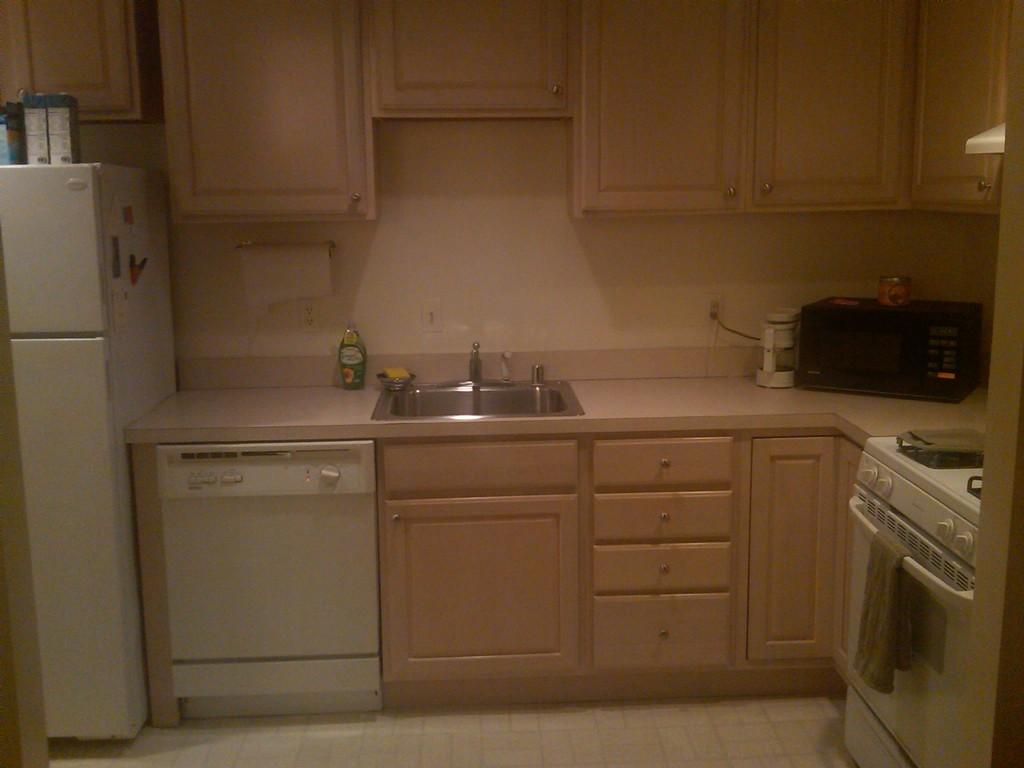What type of appliance is present in the image? There is a fridge in the image. What can be found on the shelves in the image? There are bottles in the image. What type of furniture is present in the image? There is a kitchen cabinet in the image. What is used for washing in the image? There is a sink in the image. What type of appliance is used for grinding in the image? There is a grinder in the image. What type of appliance is used for heating in the image? There is a micro oven in the image. What is visible in the background of the image? There are shelves visible in the background of the image. In which type of room might this image have been taken? The image is likely taken in a kitchen, given the presence of appliances and furniture commonly found in a kitchen. What type of hospital equipment can be seen in the image? There is no hospital equipment present in the image; it appears to be taken in a kitchen. What type of room is the image taken in, and what is the primary function of the room? The image is taken in a kitchen, which is a room primarily used for food preparation and storage. 